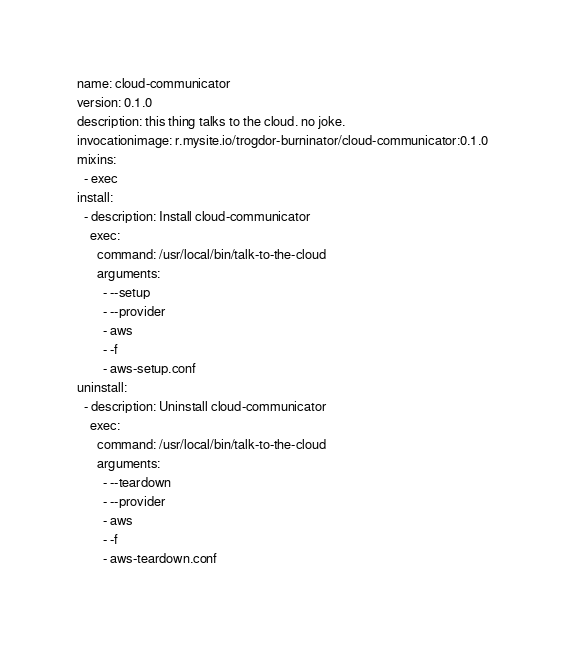<code> <loc_0><loc_0><loc_500><loc_500><_YAML_>name: cloud-communicator
version: 0.1.0
description: this thing talks to the cloud. no joke.
invocationimage: r.mysite.io/trogdor-burninator/cloud-communicator:0.1.0
mixins:
  - exec
install:
  - description: Install cloud-communicator
    exec:
      command: /usr/local/bin/talk-to-the-cloud
      arguments:
        - --setup
        - --provider
        - aws
        - -f
        - aws-setup.conf
uninstall:
  - description: Uninstall cloud-communicator
    exec:
      command: /usr/local/bin/talk-to-the-cloud
      arguments:
        - --teardown
        - --provider
        - aws
        - -f
        - aws-teardown.conf</code> 